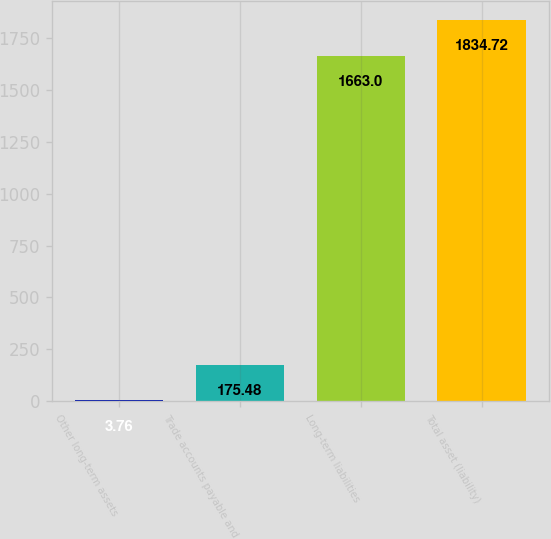Convert chart. <chart><loc_0><loc_0><loc_500><loc_500><bar_chart><fcel>Other long-term assets<fcel>Trade accounts payable and<fcel>Long-term liabilities<fcel>Total asset (liability)<nl><fcel>3.76<fcel>175.48<fcel>1663<fcel>1834.72<nl></chart> 